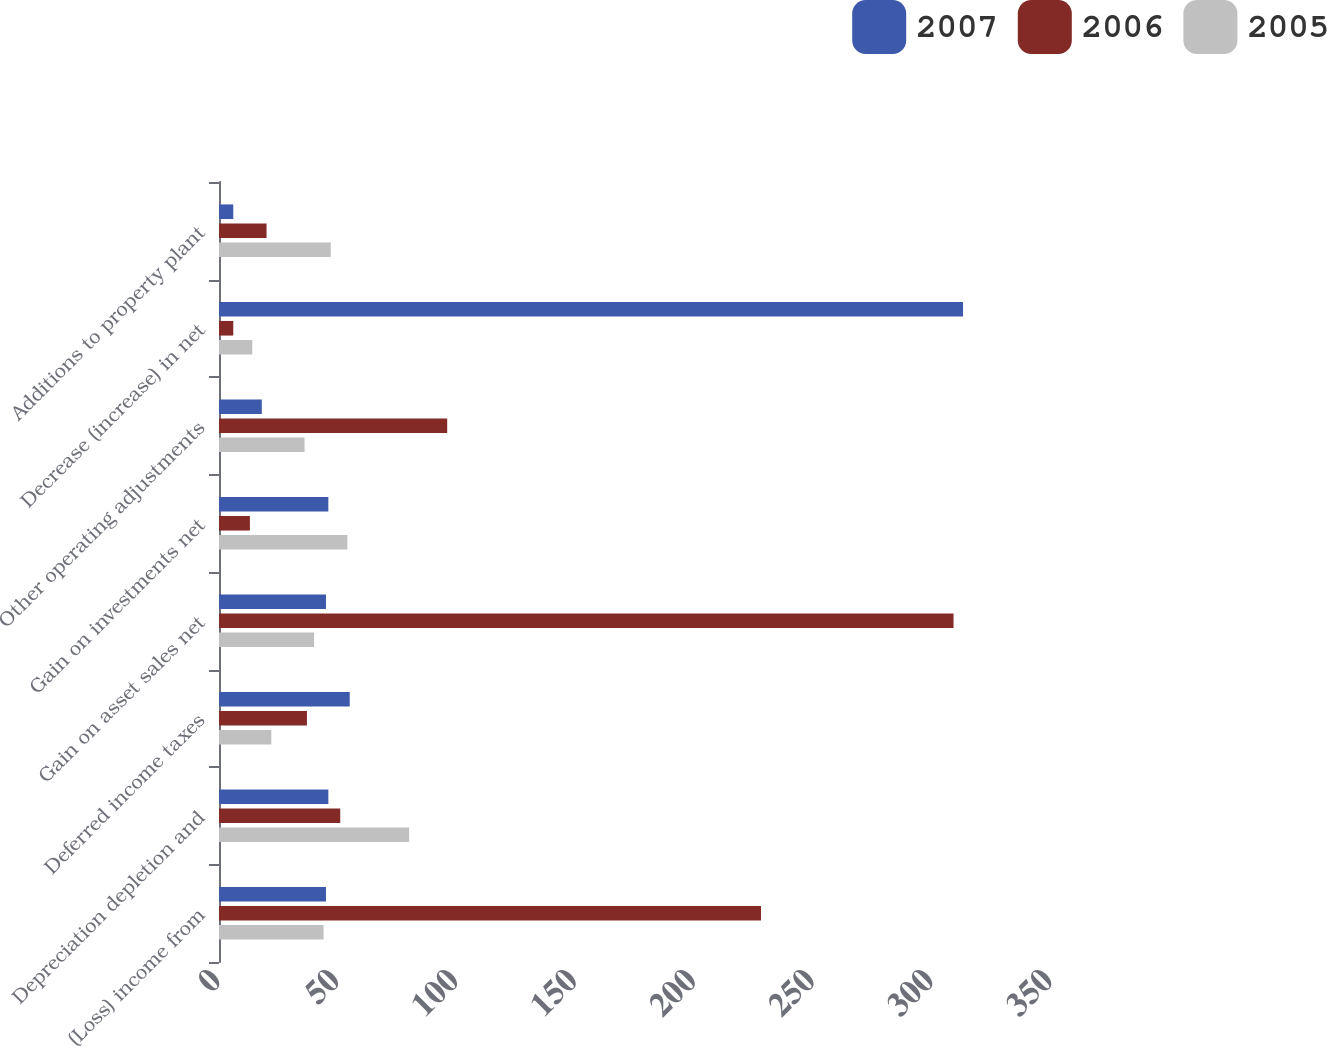Convert chart. <chart><loc_0><loc_0><loc_500><loc_500><stacked_bar_chart><ecel><fcel>(Loss) income from<fcel>Depreciation depletion and<fcel>Deferred income taxes<fcel>Gain on asset sales net<fcel>Gain on investments net<fcel>Other operating adjustments<fcel>Decrease (increase) in net<fcel>Additions to property plant<nl><fcel>2007<fcel>45<fcel>46<fcel>55<fcel>45<fcel>46<fcel>18<fcel>313<fcel>6<nl><fcel>2006<fcel>228<fcel>51<fcel>37<fcel>309<fcel>13<fcel>96<fcel>6<fcel>20<nl><fcel>2005<fcel>44<fcel>80<fcel>22<fcel>40<fcel>54<fcel>36<fcel>14<fcel>47<nl></chart> 